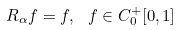Convert formula to latex. <formula><loc_0><loc_0><loc_500><loc_500>R _ { \alpha } f = f , \, \ f \in C ^ { + } _ { 0 } [ 0 , 1 ]</formula> 